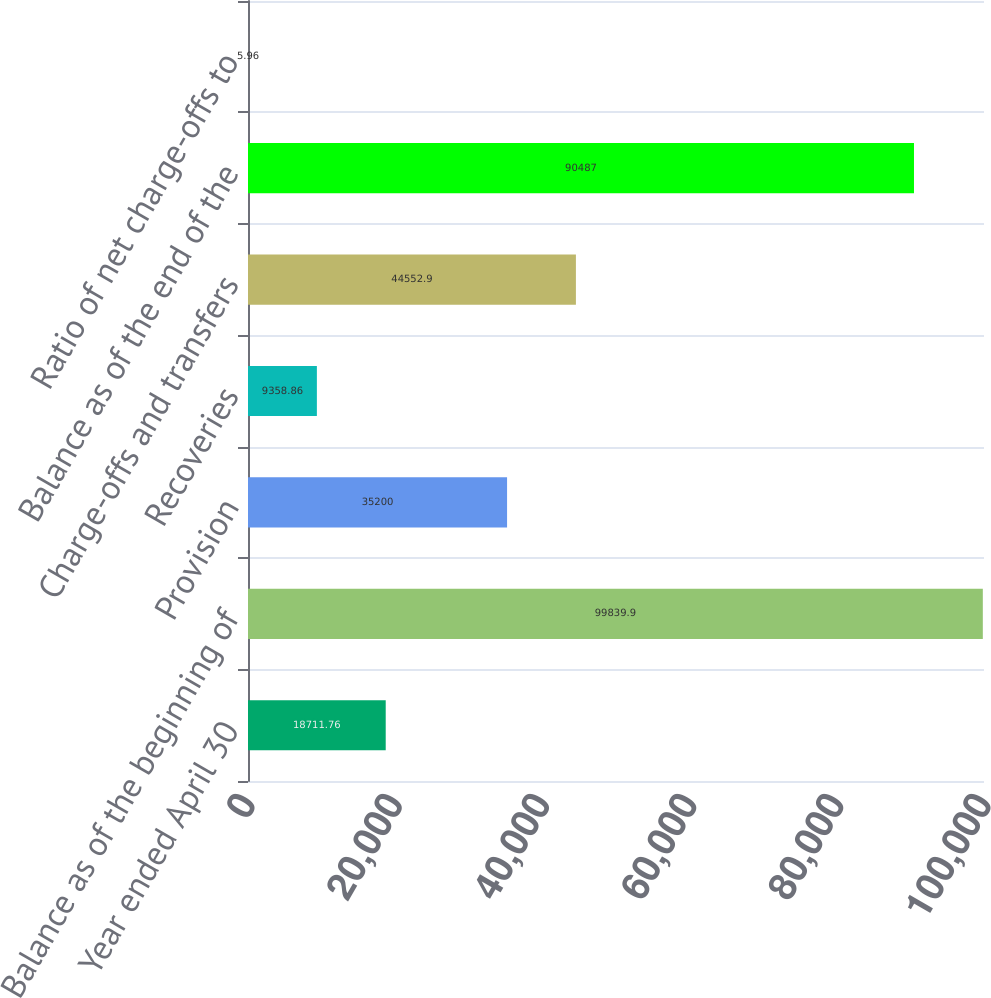Convert chart. <chart><loc_0><loc_0><loc_500><loc_500><bar_chart><fcel>Year ended April 30<fcel>Balance as of the beginning of<fcel>Provision<fcel>Recoveries<fcel>Charge-offs and transfers<fcel>Balance as of the end of the<fcel>Ratio of net charge-offs to<nl><fcel>18711.8<fcel>99839.9<fcel>35200<fcel>9358.86<fcel>44552.9<fcel>90487<fcel>5.96<nl></chart> 